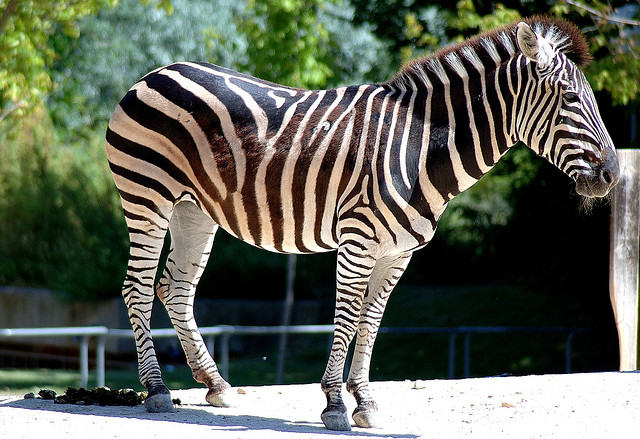<image>What is cast? I am not sure what is cast. It can be a shadow. What is cast? I don't know what 'cast' refers to in this context. It can be related to shadow. 